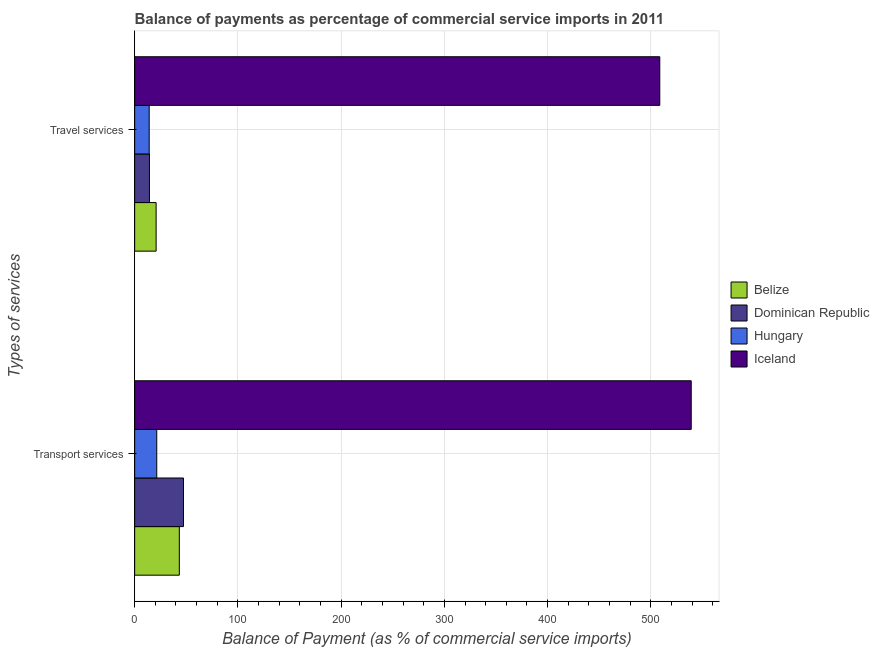How many groups of bars are there?
Keep it short and to the point. 2. How many bars are there on the 1st tick from the top?
Keep it short and to the point. 4. What is the label of the 1st group of bars from the top?
Make the answer very short. Travel services. What is the balance of payments of transport services in Iceland?
Ensure brevity in your answer.  539.07. Across all countries, what is the maximum balance of payments of transport services?
Your answer should be compact. 539.07. Across all countries, what is the minimum balance of payments of travel services?
Offer a very short reply. 14.09. In which country was the balance of payments of transport services minimum?
Your response must be concise. Hungary. What is the total balance of payments of travel services in the graph?
Give a very brief answer. 557.83. What is the difference between the balance of payments of transport services in Belize and that in Iceland?
Your response must be concise. -495.8. What is the difference between the balance of payments of transport services in Hungary and the balance of payments of travel services in Belize?
Your response must be concise. 0.59. What is the average balance of payments of travel services per country?
Give a very brief answer. 139.46. What is the difference between the balance of payments of travel services and balance of payments of transport services in Belize?
Your answer should be compact. -22.47. What is the ratio of the balance of payments of transport services in Hungary to that in Dominican Republic?
Keep it short and to the point. 0.45. Is the balance of payments of travel services in Iceland less than that in Belize?
Provide a succinct answer. No. In how many countries, is the balance of payments of transport services greater than the average balance of payments of transport services taken over all countries?
Give a very brief answer. 1. What does the 2nd bar from the top in Transport services represents?
Your response must be concise. Hungary. What does the 4th bar from the bottom in Travel services represents?
Your response must be concise. Iceland. How are the legend labels stacked?
Offer a terse response. Vertical. What is the title of the graph?
Provide a short and direct response. Balance of payments as percentage of commercial service imports in 2011. What is the label or title of the X-axis?
Keep it short and to the point. Balance of Payment (as % of commercial service imports). What is the label or title of the Y-axis?
Make the answer very short. Types of services. What is the Balance of Payment (as % of commercial service imports) in Belize in Transport services?
Offer a terse response. 43.27. What is the Balance of Payment (as % of commercial service imports) in Dominican Republic in Transport services?
Your answer should be compact. 47.28. What is the Balance of Payment (as % of commercial service imports) of Hungary in Transport services?
Ensure brevity in your answer.  21.4. What is the Balance of Payment (as % of commercial service imports) of Iceland in Transport services?
Provide a succinct answer. 539.07. What is the Balance of Payment (as % of commercial service imports) of Belize in Travel services?
Your answer should be very brief. 20.8. What is the Balance of Payment (as % of commercial service imports) in Dominican Republic in Travel services?
Ensure brevity in your answer.  14.33. What is the Balance of Payment (as % of commercial service imports) in Hungary in Travel services?
Your response must be concise. 14.09. What is the Balance of Payment (as % of commercial service imports) in Iceland in Travel services?
Provide a short and direct response. 508.61. Across all Types of services, what is the maximum Balance of Payment (as % of commercial service imports) of Belize?
Ensure brevity in your answer.  43.27. Across all Types of services, what is the maximum Balance of Payment (as % of commercial service imports) of Dominican Republic?
Your response must be concise. 47.28. Across all Types of services, what is the maximum Balance of Payment (as % of commercial service imports) of Hungary?
Your answer should be very brief. 21.4. Across all Types of services, what is the maximum Balance of Payment (as % of commercial service imports) of Iceland?
Keep it short and to the point. 539.07. Across all Types of services, what is the minimum Balance of Payment (as % of commercial service imports) in Belize?
Give a very brief answer. 20.8. Across all Types of services, what is the minimum Balance of Payment (as % of commercial service imports) of Dominican Republic?
Give a very brief answer. 14.33. Across all Types of services, what is the minimum Balance of Payment (as % of commercial service imports) of Hungary?
Your response must be concise. 14.09. Across all Types of services, what is the minimum Balance of Payment (as % of commercial service imports) in Iceland?
Your answer should be very brief. 508.61. What is the total Balance of Payment (as % of commercial service imports) of Belize in the graph?
Your response must be concise. 64.07. What is the total Balance of Payment (as % of commercial service imports) in Dominican Republic in the graph?
Offer a very short reply. 61.61. What is the total Balance of Payment (as % of commercial service imports) in Hungary in the graph?
Offer a terse response. 35.49. What is the total Balance of Payment (as % of commercial service imports) in Iceland in the graph?
Ensure brevity in your answer.  1047.68. What is the difference between the Balance of Payment (as % of commercial service imports) in Belize in Transport services and that in Travel services?
Make the answer very short. 22.47. What is the difference between the Balance of Payment (as % of commercial service imports) in Dominican Republic in Transport services and that in Travel services?
Offer a terse response. 32.96. What is the difference between the Balance of Payment (as % of commercial service imports) of Hungary in Transport services and that in Travel services?
Your response must be concise. 7.3. What is the difference between the Balance of Payment (as % of commercial service imports) of Iceland in Transport services and that in Travel services?
Your response must be concise. 30.46. What is the difference between the Balance of Payment (as % of commercial service imports) of Belize in Transport services and the Balance of Payment (as % of commercial service imports) of Dominican Republic in Travel services?
Provide a succinct answer. 28.95. What is the difference between the Balance of Payment (as % of commercial service imports) in Belize in Transport services and the Balance of Payment (as % of commercial service imports) in Hungary in Travel services?
Provide a short and direct response. 29.18. What is the difference between the Balance of Payment (as % of commercial service imports) in Belize in Transport services and the Balance of Payment (as % of commercial service imports) in Iceland in Travel services?
Your response must be concise. -465.34. What is the difference between the Balance of Payment (as % of commercial service imports) of Dominican Republic in Transport services and the Balance of Payment (as % of commercial service imports) of Hungary in Travel services?
Your answer should be compact. 33.19. What is the difference between the Balance of Payment (as % of commercial service imports) in Dominican Republic in Transport services and the Balance of Payment (as % of commercial service imports) in Iceland in Travel services?
Ensure brevity in your answer.  -461.33. What is the difference between the Balance of Payment (as % of commercial service imports) of Hungary in Transport services and the Balance of Payment (as % of commercial service imports) of Iceland in Travel services?
Make the answer very short. -487.21. What is the average Balance of Payment (as % of commercial service imports) in Belize per Types of services?
Give a very brief answer. 32.04. What is the average Balance of Payment (as % of commercial service imports) in Dominican Republic per Types of services?
Offer a very short reply. 30.8. What is the average Balance of Payment (as % of commercial service imports) of Hungary per Types of services?
Give a very brief answer. 17.75. What is the average Balance of Payment (as % of commercial service imports) in Iceland per Types of services?
Your answer should be very brief. 523.84. What is the difference between the Balance of Payment (as % of commercial service imports) in Belize and Balance of Payment (as % of commercial service imports) in Dominican Republic in Transport services?
Offer a terse response. -4.01. What is the difference between the Balance of Payment (as % of commercial service imports) in Belize and Balance of Payment (as % of commercial service imports) in Hungary in Transport services?
Make the answer very short. 21.87. What is the difference between the Balance of Payment (as % of commercial service imports) in Belize and Balance of Payment (as % of commercial service imports) in Iceland in Transport services?
Give a very brief answer. -495.8. What is the difference between the Balance of Payment (as % of commercial service imports) in Dominican Republic and Balance of Payment (as % of commercial service imports) in Hungary in Transport services?
Keep it short and to the point. 25.88. What is the difference between the Balance of Payment (as % of commercial service imports) in Dominican Republic and Balance of Payment (as % of commercial service imports) in Iceland in Transport services?
Make the answer very short. -491.79. What is the difference between the Balance of Payment (as % of commercial service imports) in Hungary and Balance of Payment (as % of commercial service imports) in Iceland in Transport services?
Provide a short and direct response. -517.67. What is the difference between the Balance of Payment (as % of commercial service imports) in Belize and Balance of Payment (as % of commercial service imports) in Dominican Republic in Travel services?
Provide a short and direct response. 6.48. What is the difference between the Balance of Payment (as % of commercial service imports) of Belize and Balance of Payment (as % of commercial service imports) of Hungary in Travel services?
Your response must be concise. 6.71. What is the difference between the Balance of Payment (as % of commercial service imports) in Belize and Balance of Payment (as % of commercial service imports) in Iceland in Travel services?
Provide a succinct answer. -487.81. What is the difference between the Balance of Payment (as % of commercial service imports) of Dominican Republic and Balance of Payment (as % of commercial service imports) of Hungary in Travel services?
Give a very brief answer. 0.23. What is the difference between the Balance of Payment (as % of commercial service imports) of Dominican Republic and Balance of Payment (as % of commercial service imports) of Iceland in Travel services?
Give a very brief answer. -494.28. What is the difference between the Balance of Payment (as % of commercial service imports) in Hungary and Balance of Payment (as % of commercial service imports) in Iceland in Travel services?
Keep it short and to the point. -494.52. What is the ratio of the Balance of Payment (as % of commercial service imports) of Belize in Transport services to that in Travel services?
Ensure brevity in your answer.  2.08. What is the ratio of the Balance of Payment (as % of commercial service imports) of Dominican Republic in Transport services to that in Travel services?
Make the answer very short. 3.3. What is the ratio of the Balance of Payment (as % of commercial service imports) of Hungary in Transport services to that in Travel services?
Offer a very short reply. 1.52. What is the ratio of the Balance of Payment (as % of commercial service imports) in Iceland in Transport services to that in Travel services?
Make the answer very short. 1.06. What is the difference between the highest and the second highest Balance of Payment (as % of commercial service imports) of Belize?
Provide a short and direct response. 22.47. What is the difference between the highest and the second highest Balance of Payment (as % of commercial service imports) of Dominican Republic?
Offer a very short reply. 32.96. What is the difference between the highest and the second highest Balance of Payment (as % of commercial service imports) in Hungary?
Give a very brief answer. 7.3. What is the difference between the highest and the second highest Balance of Payment (as % of commercial service imports) in Iceland?
Ensure brevity in your answer.  30.46. What is the difference between the highest and the lowest Balance of Payment (as % of commercial service imports) in Belize?
Provide a succinct answer. 22.47. What is the difference between the highest and the lowest Balance of Payment (as % of commercial service imports) in Dominican Republic?
Make the answer very short. 32.96. What is the difference between the highest and the lowest Balance of Payment (as % of commercial service imports) in Hungary?
Offer a very short reply. 7.3. What is the difference between the highest and the lowest Balance of Payment (as % of commercial service imports) in Iceland?
Ensure brevity in your answer.  30.46. 